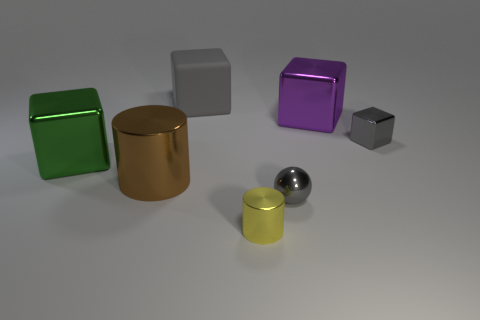Is the number of large green metal cubes left of the large green metal object less than the number of yellow objects that are right of the yellow metal cylinder?
Ensure brevity in your answer.  No. How many other objects are there of the same material as the green object?
Provide a succinct answer. 5. Are the yellow cylinder and the purple thing made of the same material?
Make the answer very short. Yes. How many other things are the same size as the green metallic cube?
Provide a short and direct response. 3. There is a gray metallic object right of the large thing that is on the right side of the tiny yellow metal cylinder; what size is it?
Make the answer very short. Small. What color is the large cube that is on the right side of the tiny gray metal object in front of the metal cube that is on the right side of the purple object?
Give a very brief answer. Purple. There is a metallic thing that is both on the right side of the green thing and to the left of the big gray rubber thing; what size is it?
Your response must be concise. Large. What number of other objects are there of the same shape as the large gray rubber object?
Ensure brevity in your answer.  3. How many cylinders are green metallic things or metallic things?
Your answer should be compact. 2. There is a large shiny block that is on the right side of the large cube that is on the left side of the large gray rubber block; are there any small gray things that are behind it?
Your answer should be compact. No. 